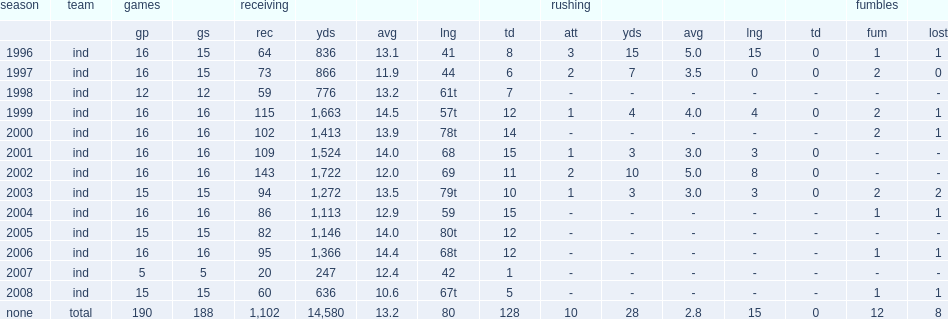How many receptions did marvin harrison get in 2002? 143.0. 